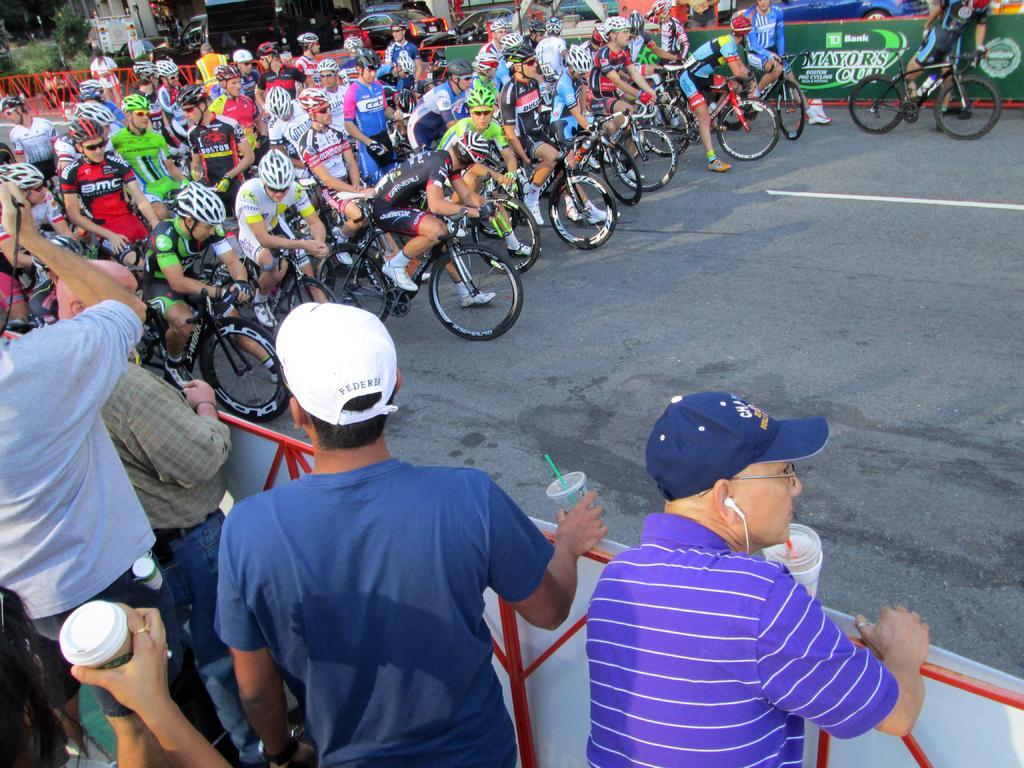Describe this image in one or two sentences. On the road there are many people riding a bicycle. To the left bottom there are four people standing and holding glass in their hand. To the left corner a man with grey t-shirt is standing and holding a camera in his hands. And in the background we can see some cars, poster and some vehicles. 